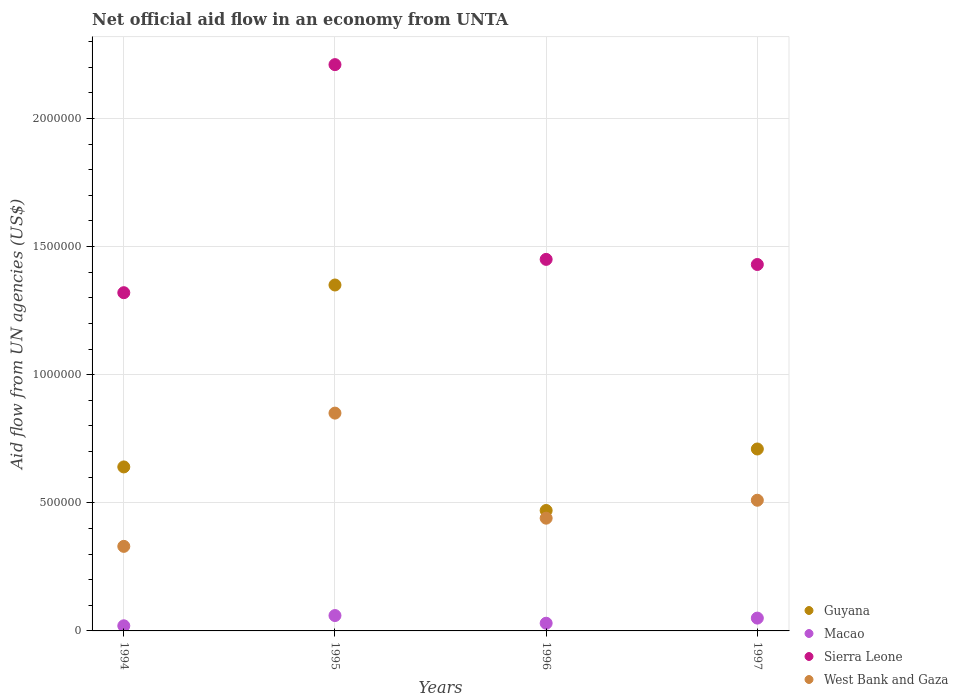Is the number of dotlines equal to the number of legend labels?
Keep it short and to the point. Yes. What is the net official aid flow in Sierra Leone in 1994?
Ensure brevity in your answer.  1.32e+06. Across all years, what is the maximum net official aid flow in Macao?
Make the answer very short. 6.00e+04. Across all years, what is the minimum net official aid flow in Sierra Leone?
Provide a succinct answer. 1.32e+06. In which year was the net official aid flow in Macao maximum?
Ensure brevity in your answer.  1995. What is the total net official aid flow in West Bank and Gaza in the graph?
Your response must be concise. 2.13e+06. What is the difference between the net official aid flow in Macao in 1994 and that in 1997?
Your answer should be very brief. -3.00e+04. What is the difference between the net official aid flow in Macao in 1994 and the net official aid flow in Sierra Leone in 1995?
Offer a very short reply. -2.19e+06. In the year 1997, what is the difference between the net official aid flow in Sierra Leone and net official aid flow in West Bank and Gaza?
Your response must be concise. 9.20e+05. Is the net official aid flow in West Bank and Gaza in 1994 less than that in 1997?
Ensure brevity in your answer.  Yes. What is the difference between the highest and the second highest net official aid flow in Sierra Leone?
Ensure brevity in your answer.  7.60e+05. What is the difference between the highest and the lowest net official aid flow in West Bank and Gaza?
Your answer should be compact. 5.20e+05. In how many years, is the net official aid flow in West Bank and Gaza greater than the average net official aid flow in West Bank and Gaza taken over all years?
Your response must be concise. 1. Is the sum of the net official aid flow in West Bank and Gaza in 1994 and 1997 greater than the maximum net official aid flow in Sierra Leone across all years?
Make the answer very short. No. Does the net official aid flow in Guyana monotonically increase over the years?
Give a very brief answer. No. Is the net official aid flow in Guyana strictly less than the net official aid flow in Sierra Leone over the years?
Keep it short and to the point. Yes. How many years are there in the graph?
Give a very brief answer. 4. What is the difference between two consecutive major ticks on the Y-axis?
Give a very brief answer. 5.00e+05. Where does the legend appear in the graph?
Your answer should be compact. Bottom right. How are the legend labels stacked?
Provide a succinct answer. Vertical. What is the title of the graph?
Give a very brief answer. Net official aid flow in an economy from UNTA. What is the label or title of the X-axis?
Your response must be concise. Years. What is the label or title of the Y-axis?
Provide a short and direct response. Aid flow from UN agencies (US$). What is the Aid flow from UN agencies (US$) in Guyana in 1994?
Give a very brief answer. 6.40e+05. What is the Aid flow from UN agencies (US$) of Sierra Leone in 1994?
Your answer should be compact. 1.32e+06. What is the Aid flow from UN agencies (US$) in West Bank and Gaza in 1994?
Ensure brevity in your answer.  3.30e+05. What is the Aid flow from UN agencies (US$) in Guyana in 1995?
Make the answer very short. 1.35e+06. What is the Aid flow from UN agencies (US$) in Macao in 1995?
Your answer should be compact. 6.00e+04. What is the Aid flow from UN agencies (US$) in Sierra Leone in 1995?
Your response must be concise. 2.21e+06. What is the Aid flow from UN agencies (US$) of West Bank and Gaza in 1995?
Your answer should be very brief. 8.50e+05. What is the Aid flow from UN agencies (US$) in Guyana in 1996?
Make the answer very short. 4.70e+05. What is the Aid flow from UN agencies (US$) in Sierra Leone in 1996?
Make the answer very short. 1.45e+06. What is the Aid flow from UN agencies (US$) in Guyana in 1997?
Keep it short and to the point. 7.10e+05. What is the Aid flow from UN agencies (US$) of Sierra Leone in 1997?
Your answer should be compact. 1.43e+06. What is the Aid flow from UN agencies (US$) in West Bank and Gaza in 1997?
Keep it short and to the point. 5.10e+05. Across all years, what is the maximum Aid flow from UN agencies (US$) in Guyana?
Your answer should be compact. 1.35e+06. Across all years, what is the maximum Aid flow from UN agencies (US$) of Macao?
Your response must be concise. 6.00e+04. Across all years, what is the maximum Aid flow from UN agencies (US$) in Sierra Leone?
Keep it short and to the point. 2.21e+06. Across all years, what is the maximum Aid flow from UN agencies (US$) in West Bank and Gaza?
Give a very brief answer. 8.50e+05. Across all years, what is the minimum Aid flow from UN agencies (US$) of Sierra Leone?
Offer a terse response. 1.32e+06. What is the total Aid flow from UN agencies (US$) in Guyana in the graph?
Your answer should be compact. 3.17e+06. What is the total Aid flow from UN agencies (US$) in Macao in the graph?
Your answer should be very brief. 1.60e+05. What is the total Aid flow from UN agencies (US$) of Sierra Leone in the graph?
Your response must be concise. 6.41e+06. What is the total Aid flow from UN agencies (US$) in West Bank and Gaza in the graph?
Keep it short and to the point. 2.13e+06. What is the difference between the Aid flow from UN agencies (US$) of Guyana in 1994 and that in 1995?
Your response must be concise. -7.10e+05. What is the difference between the Aid flow from UN agencies (US$) of Sierra Leone in 1994 and that in 1995?
Ensure brevity in your answer.  -8.90e+05. What is the difference between the Aid flow from UN agencies (US$) of West Bank and Gaza in 1994 and that in 1995?
Your answer should be very brief. -5.20e+05. What is the difference between the Aid flow from UN agencies (US$) in Guyana in 1994 and that in 1996?
Provide a succinct answer. 1.70e+05. What is the difference between the Aid flow from UN agencies (US$) in Macao in 1994 and that in 1996?
Your answer should be very brief. -10000. What is the difference between the Aid flow from UN agencies (US$) in Guyana in 1995 and that in 1996?
Your answer should be very brief. 8.80e+05. What is the difference between the Aid flow from UN agencies (US$) in Sierra Leone in 1995 and that in 1996?
Give a very brief answer. 7.60e+05. What is the difference between the Aid flow from UN agencies (US$) in Guyana in 1995 and that in 1997?
Offer a very short reply. 6.40e+05. What is the difference between the Aid flow from UN agencies (US$) of Sierra Leone in 1995 and that in 1997?
Your answer should be compact. 7.80e+05. What is the difference between the Aid flow from UN agencies (US$) of Guyana in 1996 and that in 1997?
Your response must be concise. -2.40e+05. What is the difference between the Aid flow from UN agencies (US$) in Macao in 1996 and that in 1997?
Ensure brevity in your answer.  -2.00e+04. What is the difference between the Aid flow from UN agencies (US$) of Sierra Leone in 1996 and that in 1997?
Your response must be concise. 2.00e+04. What is the difference between the Aid flow from UN agencies (US$) of Guyana in 1994 and the Aid flow from UN agencies (US$) of Macao in 1995?
Keep it short and to the point. 5.80e+05. What is the difference between the Aid flow from UN agencies (US$) of Guyana in 1994 and the Aid flow from UN agencies (US$) of Sierra Leone in 1995?
Offer a terse response. -1.57e+06. What is the difference between the Aid flow from UN agencies (US$) of Guyana in 1994 and the Aid flow from UN agencies (US$) of West Bank and Gaza in 1995?
Make the answer very short. -2.10e+05. What is the difference between the Aid flow from UN agencies (US$) of Macao in 1994 and the Aid flow from UN agencies (US$) of Sierra Leone in 1995?
Make the answer very short. -2.19e+06. What is the difference between the Aid flow from UN agencies (US$) of Macao in 1994 and the Aid flow from UN agencies (US$) of West Bank and Gaza in 1995?
Give a very brief answer. -8.30e+05. What is the difference between the Aid flow from UN agencies (US$) of Guyana in 1994 and the Aid flow from UN agencies (US$) of Sierra Leone in 1996?
Provide a succinct answer. -8.10e+05. What is the difference between the Aid flow from UN agencies (US$) in Guyana in 1994 and the Aid flow from UN agencies (US$) in West Bank and Gaza in 1996?
Provide a short and direct response. 2.00e+05. What is the difference between the Aid flow from UN agencies (US$) in Macao in 1994 and the Aid flow from UN agencies (US$) in Sierra Leone in 1996?
Keep it short and to the point. -1.43e+06. What is the difference between the Aid flow from UN agencies (US$) in Macao in 1994 and the Aid flow from UN agencies (US$) in West Bank and Gaza in 1996?
Ensure brevity in your answer.  -4.20e+05. What is the difference between the Aid flow from UN agencies (US$) in Sierra Leone in 1994 and the Aid flow from UN agencies (US$) in West Bank and Gaza in 1996?
Your answer should be compact. 8.80e+05. What is the difference between the Aid flow from UN agencies (US$) of Guyana in 1994 and the Aid flow from UN agencies (US$) of Macao in 1997?
Your response must be concise. 5.90e+05. What is the difference between the Aid flow from UN agencies (US$) of Guyana in 1994 and the Aid flow from UN agencies (US$) of Sierra Leone in 1997?
Provide a short and direct response. -7.90e+05. What is the difference between the Aid flow from UN agencies (US$) in Guyana in 1994 and the Aid flow from UN agencies (US$) in West Bank and Gaza in 1997?
Your answer should be compact. 1.30e+05. What is the difference between the Aid flow from UN agencies (US$) in Macao in 1994 and the Aid flow from UN agencies (US$) in Sierra Leone in 1997?
Give a very brief answer. -1.41e+06. What is the difference between the Aid flow from UN agencies (US$) of Macao in 1994 and the Aid flow from UN agencies (US$) of West Bank and Gaza in 1997?
Keep it short and to the point. -4.90e+05. What is the difference between the Aid flow from UN agencies (US$) in Sierra Leone in 1994 and the Aid flow from UN agencies (US$) in West Bank and Gaza in 1997?
Provide a succinct answer. 8.10e+05. What is the difference between the Aid flow from UN agencies (US$) of Guyana in 1995 and the Aid flow from UN agencies (US$) of Macao in 1996?
Offer a very short reply. 1.32e+06. What is the difference between the Aid flow from UN agencies (US$) of Guyana in 1995 and the Aid flow from UN agencies (US$) of West Bank and Gaza in 1996?
Your response must be concise. 9.10e+05. What is the difference between the Aid flow from UN agencies (US$) in Macao in 1995 and the Aid flow from UN agencies (US$) in Sierra Leone in 1996?
Your answer should be compact. -1.39e+06. What is the difference between the Aid flow from UN agencies (US$) of Macao in 1995 and the Aid flow from UN agencies (US$) of West Bank and Gaza in 1996?
Offer a terse response. -3.80e+05. What is the difference between the Aid flow from UN agencies (US$) in Sierra Leone in 1995 and the Aid flow from UN agencies (US$) in West Bank and Gaza in 1996?
Ensure brevity in your answer.  1.77e+06. What is the difference between the Aid flow from UN agencies (US$) of Guyana in 1995 and the Aid flow from UN agencies (US$) of Macao in 1997?
Give a very brief answer. 1.30e+06. What is the difference between the Aid flow from UN agencies (US$) in Guyana in 1995 and the Aid flow from UN agencies (US$) in Sierra Leone in 1997?
Provide a succinct answer. -8.00e+04. What is the difference between the Aid flow from UN agencies (US$) of Guyana in 1995 and the Aid flow from UN agencies (US$) of West Bank and Gaza in 1997?
Provide a short and direct response. 8.40e+05. What is the difference between the Aid flow from UN agencies (US$) in Macao in 1995 and the Aid flow from UN agencies (US$) in Sierra Leone in 1997?
Offer a very short reply. -1.37e+06. What is the difference between the Aid flow from UN agencies (US$) in Macao in 1995 and the Aid flow from UN agencies (US$) in West Bank and Gaza in 1997?
Offer a very short reply. -4.50e+05. What is the difference between the Aid flow from UN agencies (US$) of Sierra Leone in 1995 and the Aid flow from UN agencies (US$) of West Bank and Gaza in 1997?
Give a very brief answer. 1.70e+06. What is the difference between the Aid flow from UN agencies (US$) in Guyana in 1996 and the Aid flow from UN agencies (US$) in Macao in 1997?
Keep it short and to the point. 4.20e+05. What is the difference between the Aid flow from UN agencies (US$) of Guyana in 1996 and the Aid flow from UN agencies (US$) of Sierra Leone in 1997?
Your response must be concise. -9.60e+05. What is the difference between the Aid flow from UN agencies (US$) in Guyana in 1996 and the Aid flow from UN agencies (US$) in West Bank and Gaza in 1997?
Give a very brief answer. -4.00e+04. What is the difference between the Aid flow from UN agencies (US$) of Macao in 1996 and the Aid flow from UN agencies (US$) of Sierra Leone in 1997?
Your response must be concise. -1.40e+06. What is the difference between the Aid flow from UN agencies (US$) of Macao in 1996 and the Aid flow from UN agencies (US$) of West Bank and Gaza in 1997?
Ensure brevity in your answer.  -4.80e+05. What is the difference between the Aid flow from UN agencies (US$) of Sierra Leone in 1996 and the Aid flow from UN agencies (US$) of West Bank and Gaza in 1997?
Ensure brevity in your answer.  9.40e+05. What is the average Aid flow from UN agencies (US$) of Guyana per year?
Provide a succinct answer. 7.92e+05. What is the average Aid flow from UN agencies (US$) in Sierra Leone per year?
Provide a succinct answer. 1.60e+06. What is the average Aid flow from UN agencies (US$) of West Bank and Gaza per year?
Make the answer very short. 5.32e+05. In the year 1994, what is the difference between the Aid flow from UN agencies (US$) of Guyana and Aid flow from UN agencies (US$) of Macao?
Give a very brief answer. 6.20e+05. In the year 1994, what is the difference between the Aid flow from UN agencies (US$) in Guyana and Aid flow from UN agencies (US$) in Sierra Leone?
Your answer should be compact. -6.80e+05. In the year 1994, what is the difference between the Aid flow from UN agencies (US$) in Guyana and Aid flow from UN agencies (US$) in West Bank and Gaza?
Give a very brief answer. 3.10e+05. In the year 1994, what is the difference between the Aid flow from UN agencies (US$) of Macao and Aid flow from UN agencies (US$) of Sierra Leone?
Keep it short and to the point. -1.30e+06. In the year 1994, what is the difference between the Aid flow from UN agencies (US$) of Macao and Aid flow from UN agencies (US$) of West Bank and Gaza?
Provide a succinct answer. -3.10e+05. In the year 1994, what is the difference between the Aid flow from UN agencies (US$) in Sierra Leone and Aid flow from UN agencies (US$) in West Bank and Gaza?
Your answer should be very brief. 9.90e+05. In the year 1995, what is the difference between the Aid flow from UN agencies (US$) of Guyana and Aid flow from UN agencies (US$) of Macao?
Provide a succinct answer. 1.29e+06. In the year 1995, what is the difference between the Aid flow from UN agencies (US$) in Guyana and Aid flow from UN agencies (US$) in Sierra Leone?
Your response must be concise. -8.60e+05. In the year 1995, what is the difference between the Aid flow from UN agencies (US$) in Guyana and Aid flow from UN agencies (US$) in West Bank and Gaza?
Ensure brevity in your answer.  5.00e+05. In the year 1995, what is the difference between the Aid flow from UN agencies (US$) of Macao and Aid flow from UN agencies (US$) of Sierra Leone?
Your answer should be very brief. -2.15e+06. In the year 1995, what is the difference between the Aid flow from UN agencies (US$) of Macao and Aid flow from UN agencies (US$) of West Bank and Gaza?
Your answer should be very brief. -7.90e+05. In the year 1995, what is the difference between the Aid flow from UN agencies (US$) in Sierra Leone and Aid flow from UN agencies (US$) in West Bank and Gaza?
Your answer should be very brief. 1.36e+06. In the year 1996, what is the difference between the Aid flow from UN agencies (US$) in Guyana and Aid flow from UN agencies (US$) in Macao?
Your response must be concise. 4.40e+05. In the year 1996, what is the difference between the Aid flow from UN agencies (US$) in Guyana and Aid flow from UN agencies (US$) in Sierra Leone?
Give a very brief answer. -9.80e+05. In the year 1996, what is the difference between the Aid flow from UN agencies (US$) in Guyana and Aid flow from UN agencies (US$) in West Bank and Gaza?
Offer a terse response. 3.00e+04. In the year 1996, what is the difference between the Aid flow from UN agencies (US$) of Macao and Aid flow from UN agencies (US$) of Sierra Leone?
Ensure brevity in your answer.  -1.42e+06. In the year 1996, what is the difference between the Aid flow from UN agencies (US$) of Macao and Aid flow from UN agencies (US$) of West Bank and Gaza?
Your answer should be compact. -4.10e+05. In the year 1996, what is the difference between the Aid flow from UN agencies (US$) in Sierra Leone and Aid flow from UN agencies (US$) in West Bank and Gaza?
Keep it short and to the point. 1.01e+06. In the year 1997, what is the difference between the Aid flow from UN agencies (US$) of Guyana and Aid flow from UN agencies (US$) of Macao?
Provide a succinct answer. 6.60e+05. In the year 1997, what is the difference between the Aid flow from UN agencies (US$) in Guyana and Aid flow from UN agencies (US$) in Sierra Leone?
Your response must be concise. -7.20e+05. In the year 1997, what is the difference between the Aid flow from UN agencies (US$) in Guyana and Aid flow from UN agencies (US$) in West Bank and Gaza?
Provide a short and direct response. 2.00e+05. In the year 1997, what is the difference between the Aid flow from UN agencies (US$) of Macao and Aid flow from UN agencies (US$) of Sierra Leone?
Your response must be concise. -1.38e+06. In the year 1997, what is the difference between the Aid flow from UN agencies (US$) of Macao and Aid flow from UN agencies (US$) of West Bank and Gaza?
Your answer should be compact. -4.60e+05. In the year 1997, what is the difference between the Aid flow from UN agencies (US$) of Sierra Leone and Aid flow from UN agencies (US$) of West Bank and Gaza?
Your response must be concise. 9.20e+05. What is the ratio of the Aid flow from UN agencies (US$) of Guyana in 1994 to that in 1995?
Your answer should be compact. 0.47. What is the ratio of the Aid flow from UN agencies (US$) in Sierra Leone in 1994 to that in 1995?
Provide a short and direct response. 0.6. What is the ratio of the Aid flow from UN agencies (US$) of West Bank and Gaza in 1994 to that in 1995?
Your answer should be compact. 0.39. What is the ratio of the Aid flow from UN agencies (US$) of Guyana in 1994 to that in 1996?
Make the answer very short. 1.36. What is the ratio of the Aid flow from UN agencies (US$) of Sierra Leone in 1994 to that in 1996?
Ensure brevity in your answer.  0.91. What is the ratio of the Aid flow from UN agencies (US$) in Guyana in 1994 to that in 1997?
Your response must be concise. 0.9. What is the ratio of the Aid flow from UN agencies (US$) of Macao in 1994 to that in 1997?
Offer a very short reply. 0.4. What is the ratio of the Aid flow from UN agencies (US$) of Sierra Leone in 1994 to that in 1997?
Your answer should be very brief. 0.92. What is the ratio of the Aid flow from UN agencies (US$) in West Bank and Gaza in 1994 to that in 1997?
Your answer should be compact. 0.65. What is the ratio of the Aid flow from UN agencies (US$) in Guyana in 1995 to that in 1996?
Your response must be concise. 2.87. What is the ratio of the Aid flow from UN agencies (US$) in Sierra Leone in 1995 to that in 1996?
Provide a succinct answer. 1.52. What is the ratio of the Aid flow from UN agencies (US$) of West Bank and Gaza in 1995 to that in 1996?
Ensure brevity in your answer.  1.93. What is the ratio of the Aid flow from UN agencies (US$) of Guyana in 1995 to that in 1997?
Make the answer very short. 1.9. What is the ratio of the Aid flow from UN agencies (US$) in Sierra Leone in 1995 to that in 1997?
Your response must be concise. 1.55. What is the ratio of the Aid flow from UN agencies (US$) of West Bank and Gaza in 1995 to that in 1997?
Offer a terse response. 1.67. What is the ratio of the Aid flow from UN agencies (US$) of Guyana in 1996 to that in 1997?
Offer a very short reply. 0.66. What is the ratio of the Aid flow from UN agencies (US$) of West Bank and Gaza in 1996 to that in 1997?
Give a very brief answer. 0.86. What is the difference between the highest and the second highest Aid flow from UN agencies (US$) in Guyana?
Keep it short and to the point. 6.40e+05. What is the difference between the highest and the second highest Aid flow from UN agencies (US$) of Sierra Leone?
Offer a terse response. 7.60e+05. What is the difference between the highest and the second highest Aid flow from UN agencies (US$) in West Bank and Gaza?
Keep it short and to the point. 3.40e+05. What is the difference between the highest and the lowest Aid flow from UN agencies (US$) in Guyana?
Offer a very short reply. 8.80e+05. What is the difference between the highest and the lowest Aid flow from UN agencies (US$) of Sierra Leone?
Make the answer very short. 8.90e+05. What is the difference between the highest and the lowest Aid flow from UN agencies (US$) in West Bank and Gaza?
Your response must be concise. 5.20e+05. 